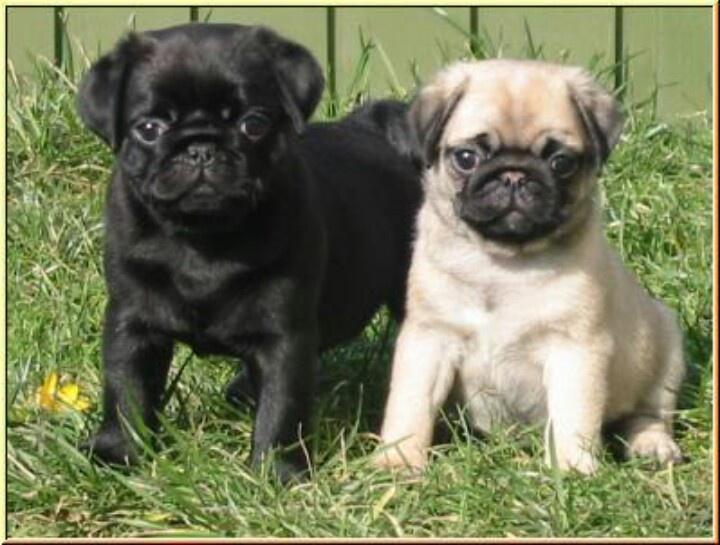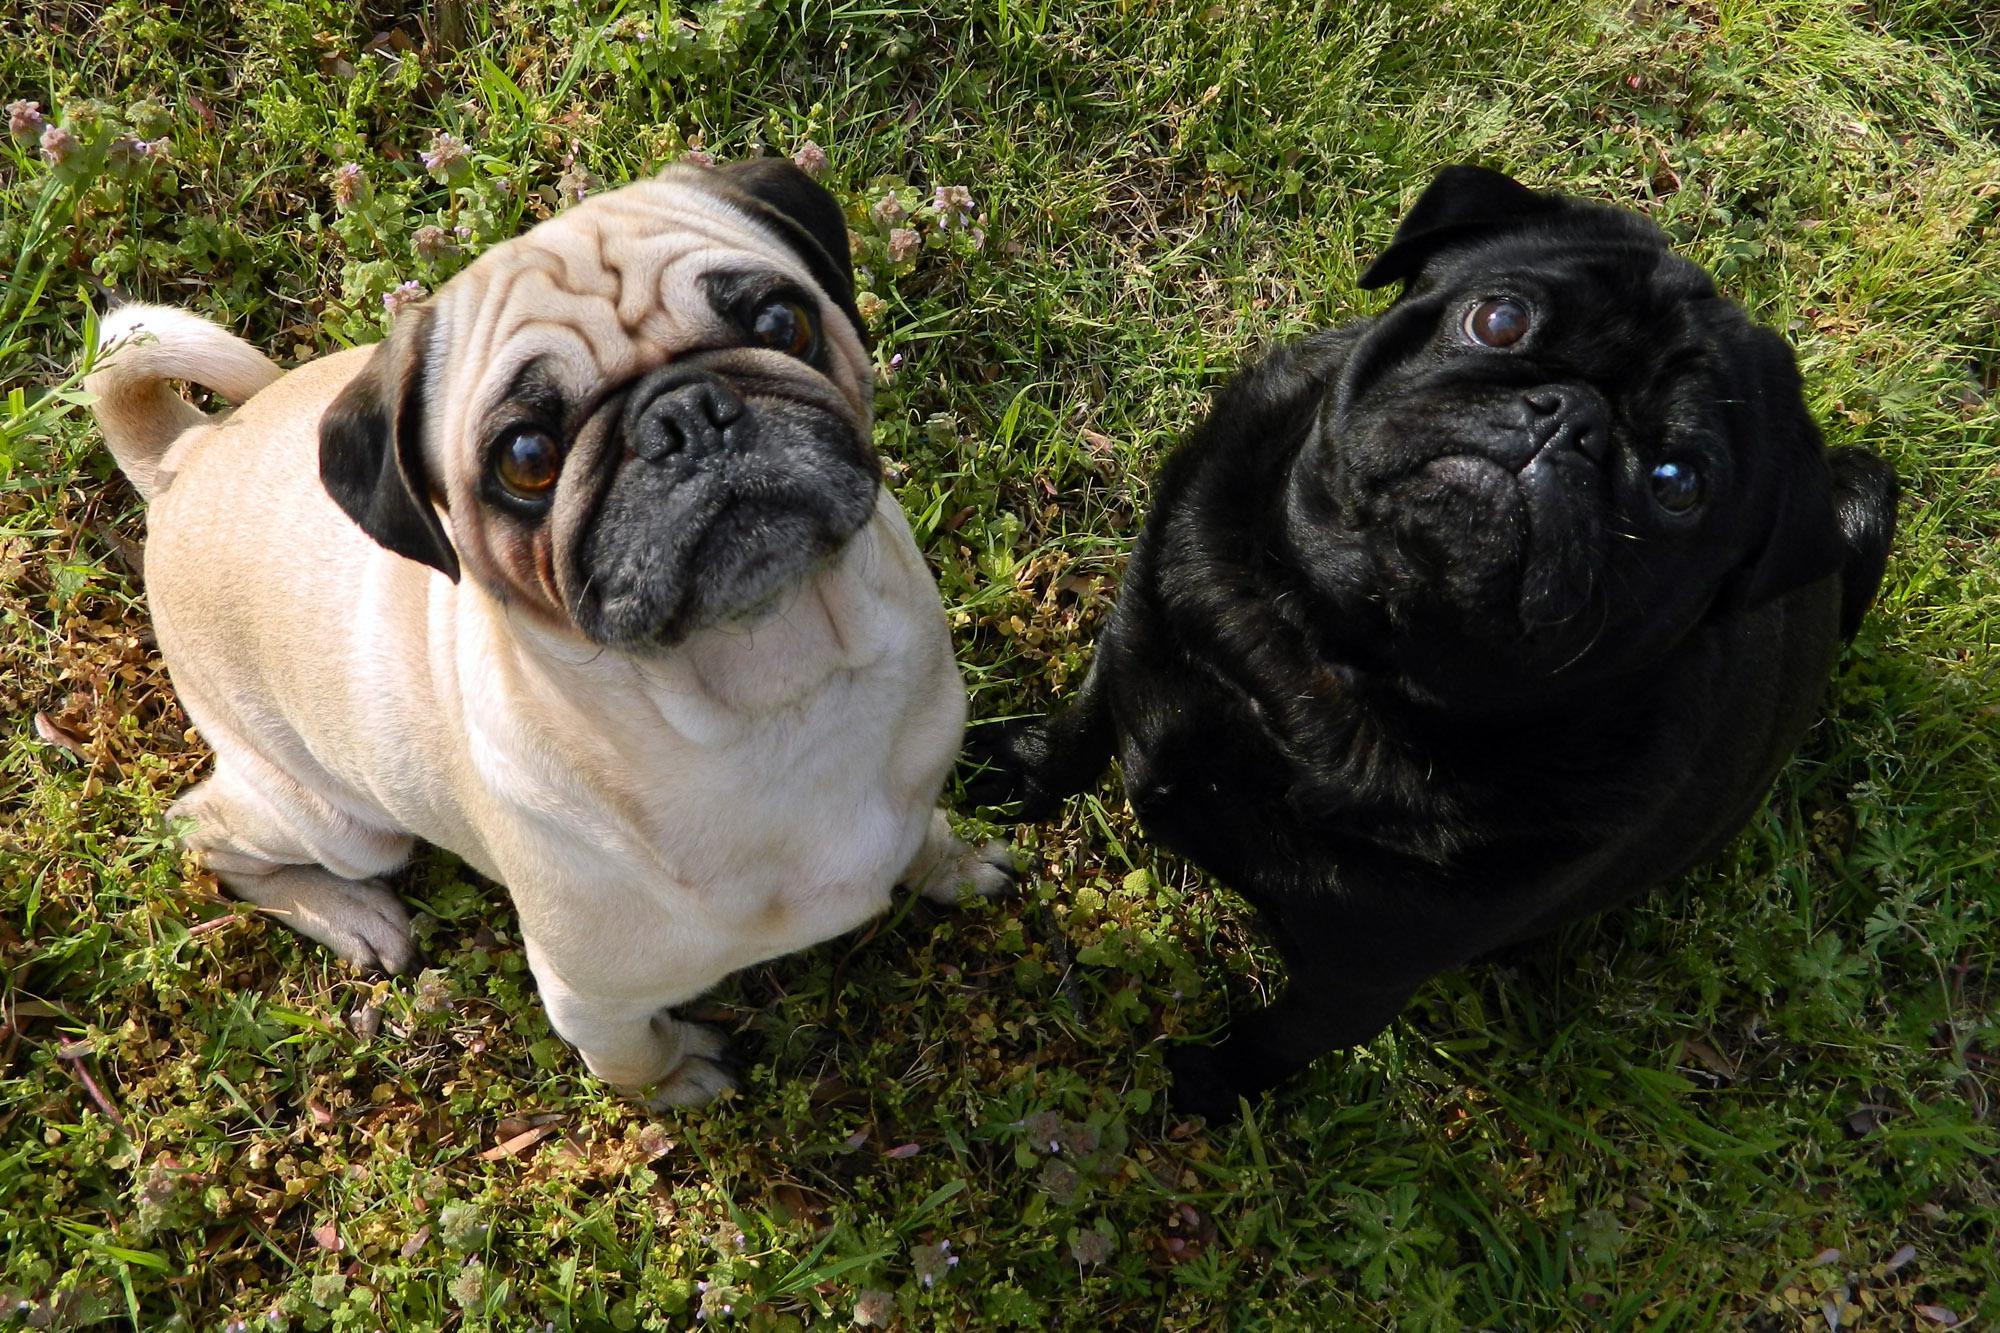The first image is the image on the left, the second image is the image on the right. Examine the images to the left and right. Is the description "There is exactly one light colored dog with a dark muzzle in each image." accurate? Answer yes or no. Yes. The first image is the image on the left, the second image is the image on the right. Assess this claim about the two images: "Each image contains multiple pugs, and each image includes at least one black pug.". Correct or not? Answer yes or no. Yes. 